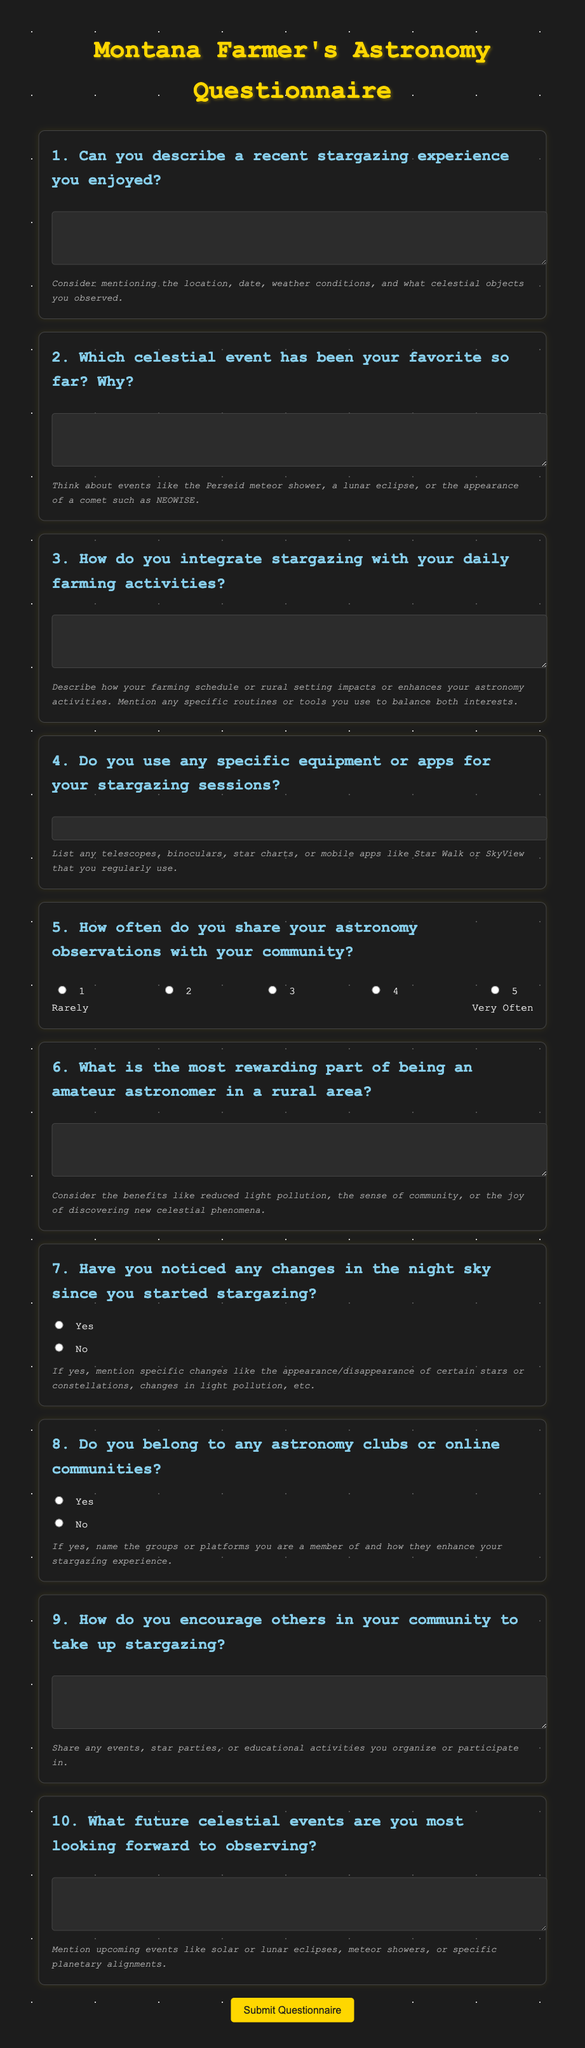What is the title of the document? The title of the document is found in the `<title>` tag and is "Montana Farmer's Astronomy Questionnaire".
Answer: Montana Farmer's Astronomy Questionnaire How many main questions are in the questionnaire? By counting the `<h2>` headings that represent each question, there are 10 main questions.
Answer: 10 What color is the background of the document? The background color is specified in the CSS as "#1c1c1c".
Answer: #1c1c1c What celestial event is mentioned as a favorite example in question 2? The specific celestial events mentioned as examples are the Perseid meteor shower, a lunar eclipse, and the appearance of a comet such as NEOWISE.
Answer: Perseid meteor shower What type of input is used for the frequency of sharing observations? The frequency of sharing observations uses radio buttons as indicated by the `<input type="radio">` elements.
Answer: Radio buttons What hint is provided for question 5? The hint provided explains the interpretation of the scoring: "Rarely" for 1 and "Very Often" for 5.
Answer: Rarely and Very Often Which input type is used for the stargazing equipment question? The stargazing equipment question uses a text input as indicated by the `<input type="text">` element.
Answer: Text input What is the color of the button used to submit the questionnaire? The submit button is specified to have a background color of "#ffd700".
Answer: #ffd700 